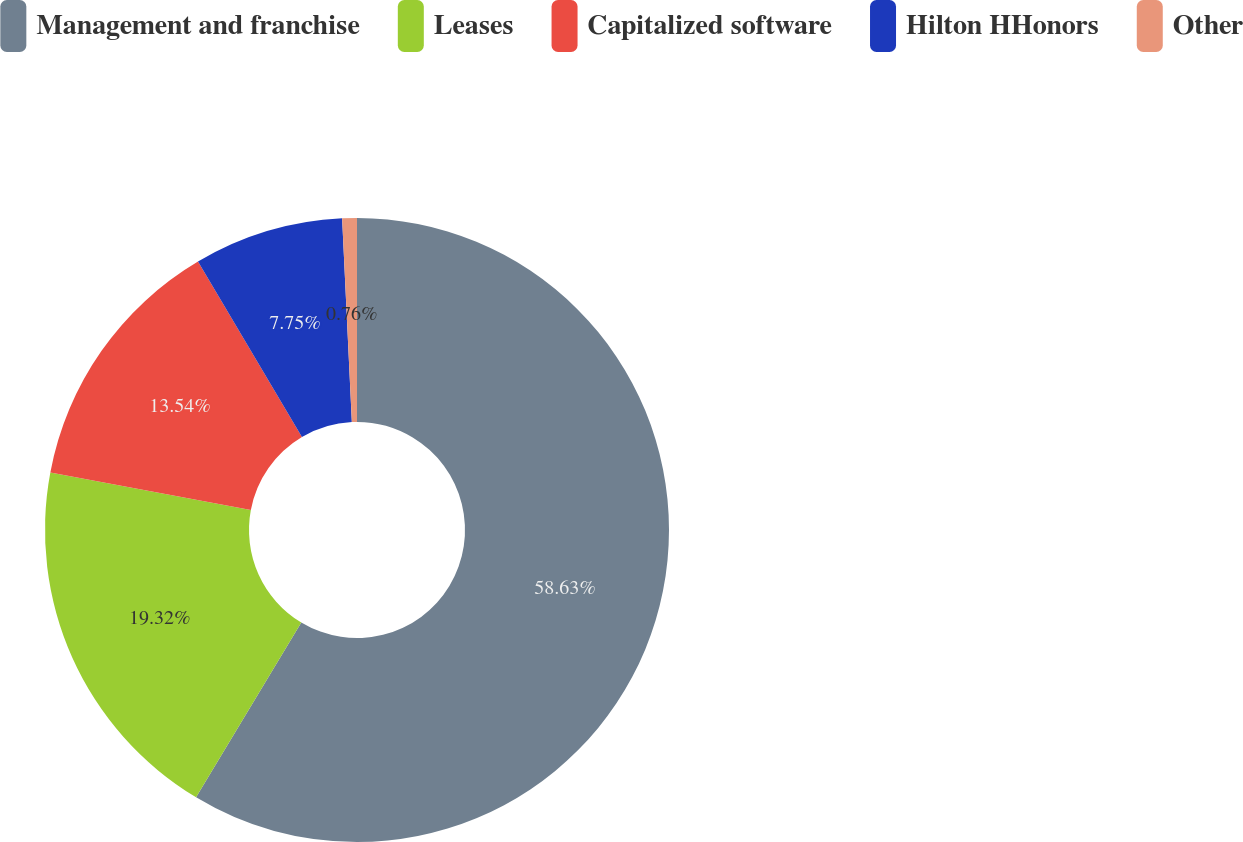Convert chart to OTSL. <chart><loc_0><loc_0><loc_500><loc_500><pie_chart><fcel>Management and franchise<fcel>Leases<fcel>Capitalized software<fcel>Hilton HHonors<fcel>Other<nl><fcel>58.62%<fcel>19.32%<fcel>13.54%<fcel>7.75%<fcel>0.76%<nl></chart> 